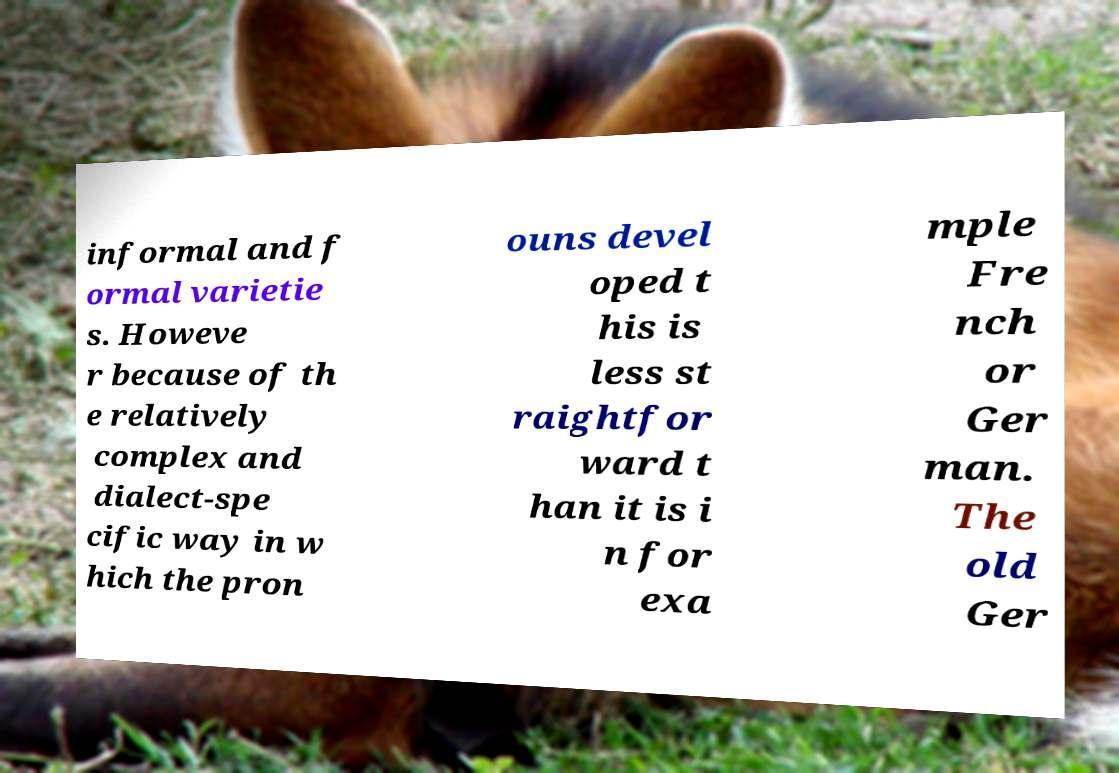Please identify and transcribe the text found in this image. informal and f ormal varietie s. Howeve r because of th e relatively complex and dialect-spe cific way in w hich the pron ouns devel oped t his is less st raightfor ward t han it is i n for exa mple Fre nch or Ger man. The old Ger 